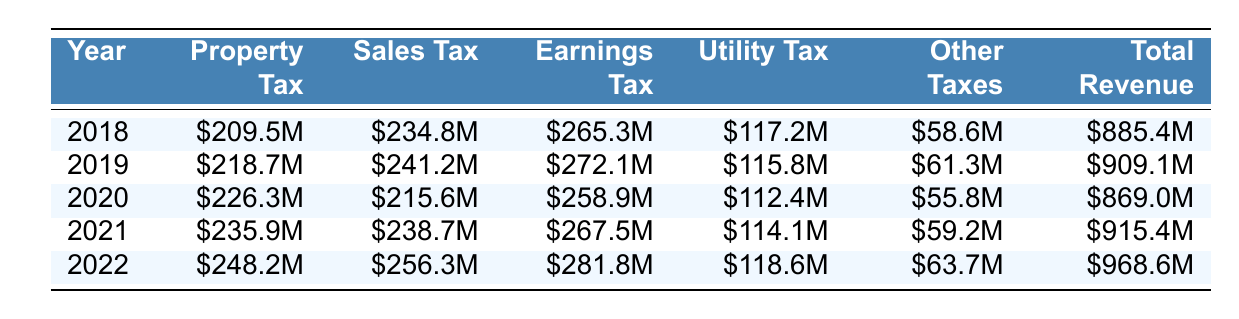What was the total revenue for Kansas City in 2022? The table shows the total revenue for the year 2022 as $968.6M.
Answer: $968.6M Which year had the highest property tax revenue? By comparing the values in the property tax column, 2022 has the highest property tax revenue at $248.2M.
Answer: 2022 What is the difference in sales tax revenue between 2018 and 2020? The sales tax revenue for 2018 is $234.8M and for 2020 it is $215.6M. The difference is $234.8M - $215.6M = $19.2M.
Answer: $19.2M Was the earnings tax revenue higher in 2021 than in 2019? The earnings tax revenue in 2021 is $267.5M, while in 2019 it is $272.1M. Since $267.5M is less than $272.1M, the statement is false.
Answer: No What was the total property tax revenue over the 5 years shown in the table? The total property tax revenue can be calculated as: $209.5M + $218.7M + $226.3M + $235.9M + $248.2M = $1,138.6M.
Answer: $1,138.6M What percentage of the total revenue in 2022 came from sales tax? The sales tax revenue in 2022 is $256.3M, and the total revenue is $968.6M. The percentage is calculated as ($256.3M / $968.6M) * 100 = 26.5%.
Answer: 26.5% How did utility tax revenue change from 2019 to 2022? In 2019, the utility tax revenue was $115.8M, and in 2022 it is $118.6M. The change is $118.6M - $115.8M = $2.8M.
Answer: Increased by $2.8M Which tax revenue category had the lowest total over the five years? By summing each category: Property Tax = $1,138.6M, Sales Tax = $1,166.6M, Earnings Tax = $1,271.6M, Utility Tax = $578.1M, Other Taxes = $298.6M. The lowest total is for Utility Tax.
Answer: Utility Tax In which year did sales tax revenue dip compared to the previous year? In 2020, sales tax revenue dropped to $215.6M from $241.2M in 2019.
Answer: 2020 What was the overall trend in total revenue from 2018 to 2022? Analyzing the total revenues: $885.4M in 2018, $909.1M in 2019, $869.0M in 2020, $915.4M in 2021, and $968.6M in 2022 shows an overall increase, except for a dip in 2020.
Answer: Overall increasing trend 